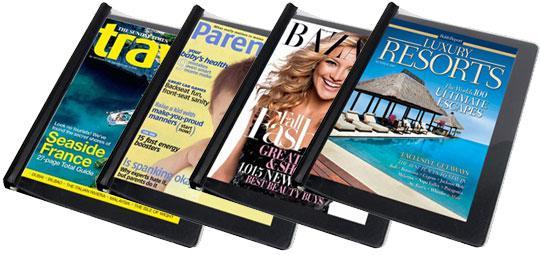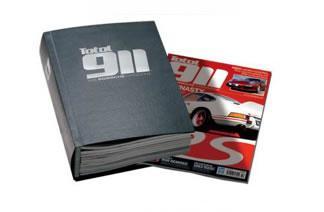The first image is the image on the left, the second image is the image on the right. Considering the images on both sides, is "There are two binders against a white background." valid? Answer yes or no. No. The first image is the image on the left, the second image is the image on the right. For the images displayed, is the sentence "The left image includes a binder with a magazine featuring a woman on the cover." factually correct? Answer yes or no. Yes. 